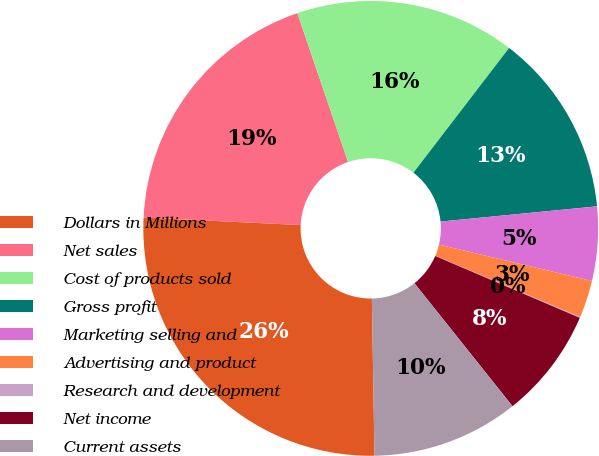<chart> <loc_0><loc_0><loc_500><loc_500><pie_chart><fcel>Dollars in Millions<fcel>Net sales<fcel>Cost of products sold<fcel>Gross profit<fcel>Marketing selling and<fcel>Advertising and product<fcel>Research and development<fcel>Net income<fcel>Current assets<nl><fcel>26.02%<fcel>19.01%<fcel>15.64%<fcel>13.04%<fcel>5.26%<fcel>2.66%<fcel>0.06%<fcel>7.85%<fcel>10.45%<nl></chart> 